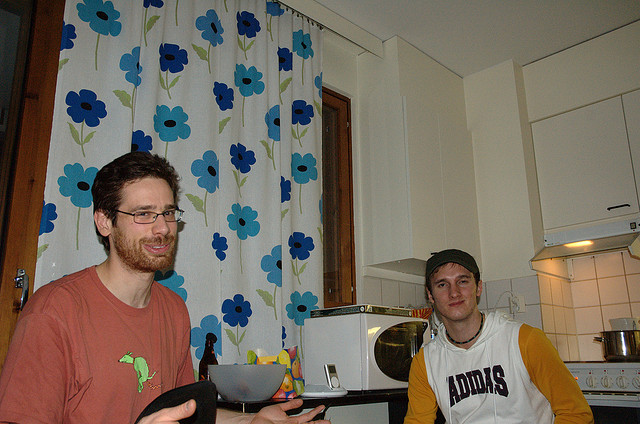<image>What game are they playing? I don't know what game they are playing. It could be poker, cards, I spy, truth or dare, or football. What game are they playing? I don't know what game they are playing. It could be poker, cards, i spy, truth or dare, or football. 